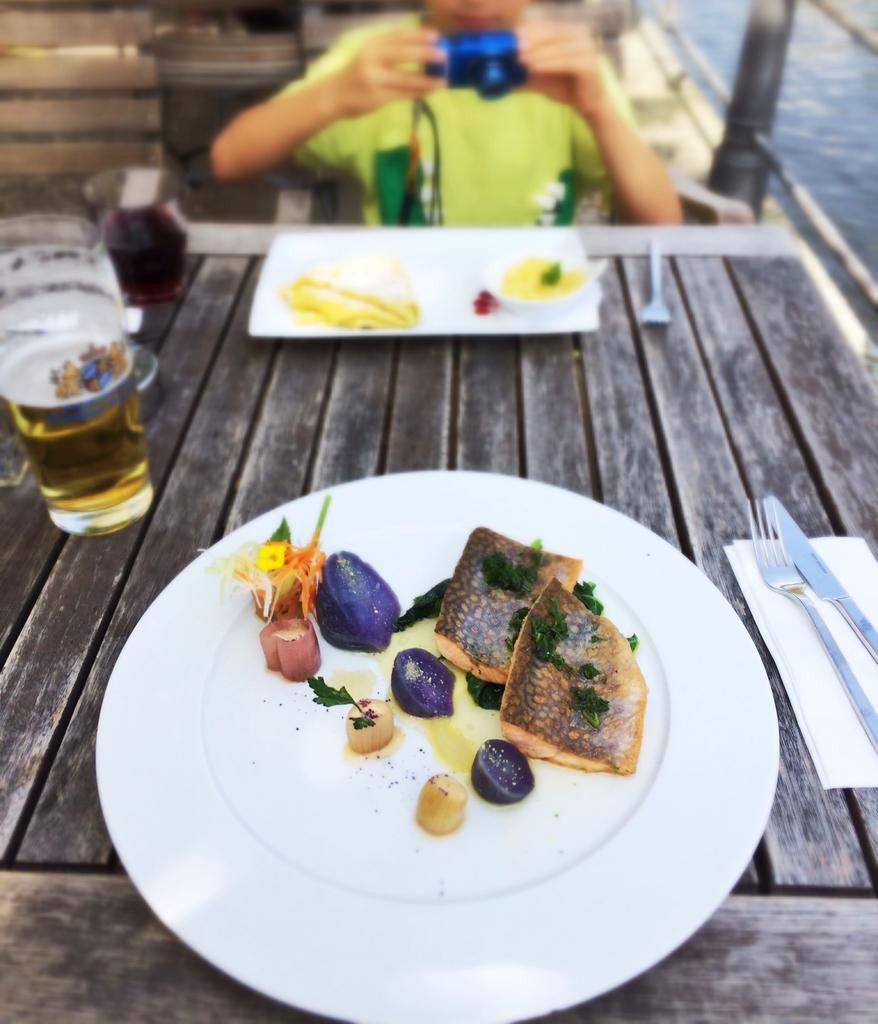What is the primary subject of the image? Food is the main focus of the image. What is on the table in the image? There is a plate, food, a fork, a knife, and a glass on the table. Who is present in the image? A person is sitting in front of the table. What is the person doing in the image? The person is sitting on a chair and holding a camera. How does the person maintain their balance while standing on one foot in the image? The person is not standing on one foot in the image; they are sitting on a chair. What type of cable is connected to the camera in the image? There is no cable connected to the camera in the image; the person is simply holding it. 